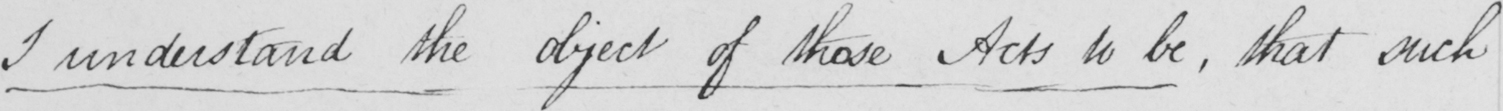Please transcribe the handwritten text in this image. I understand the objects of those Acts to be , that such 